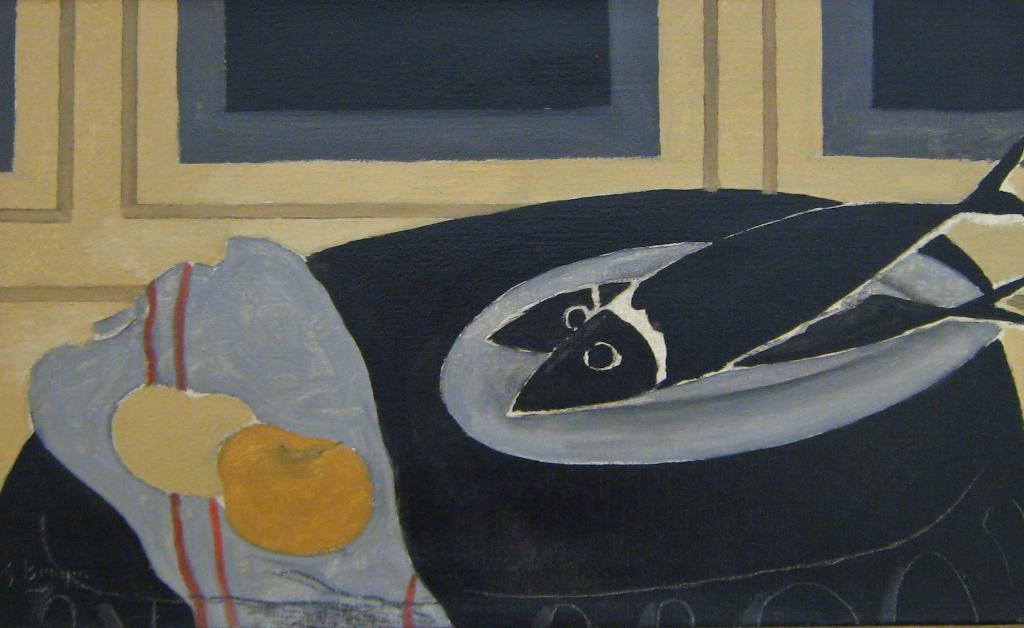Please provide a concise description of this image. This is a painting and in this painting we can see windows, fishes and a cloth. 